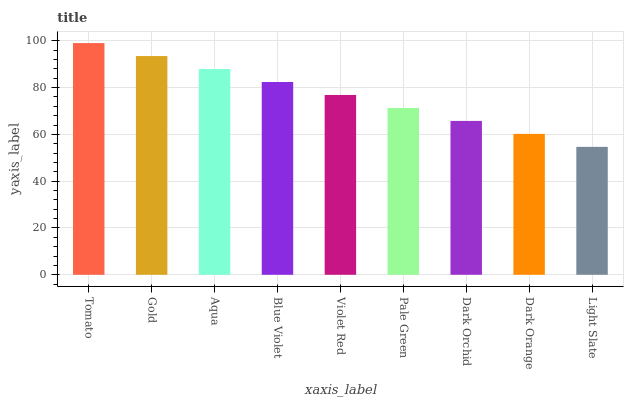Is Light Slate the minimum?
Answer yes or no. Yes. Is Tomato the maximum?
Answer yes or no. Yes. Is Gold the minimum?
Answer yes or no. No. Is Gold the maximum?
Answer yes or no. No. Is Tomato greater than Gold?
Answer yes or no. Yes. Is Gold less than Tomato?
Answer yes or no. Yes. Is Gold greater than Tomato?
Answer yes or no. No. Is Tomato less than Gold?
Answer yes or no. No. Is Violet Red the high median?
Answer yes or no. Yes. Is Violet Red the low median?
Answer yes or no. Yes. Is Dark Orchid the high median?
Answer yes or no. No. Is Blue Violet the low median?
Answer yes or no. No. 